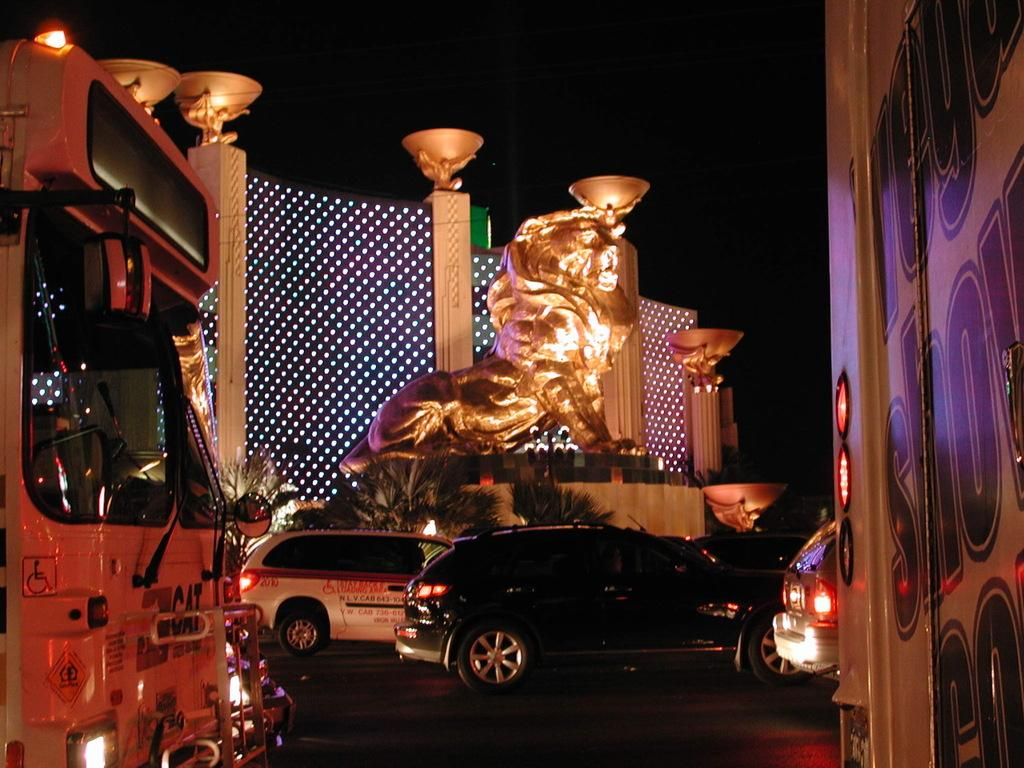What is happening on the road in the image? There are vehicles moving on the road in the image. What can be seen in the background of the image? There is a golden statue of a lion and a wall in the background. What type of vegetation is visible in the background? There are plants in the background. What type of leather is being used to make the van in the image? There is no van present in the image, so it is not possible to determine what type of leather might be used. 